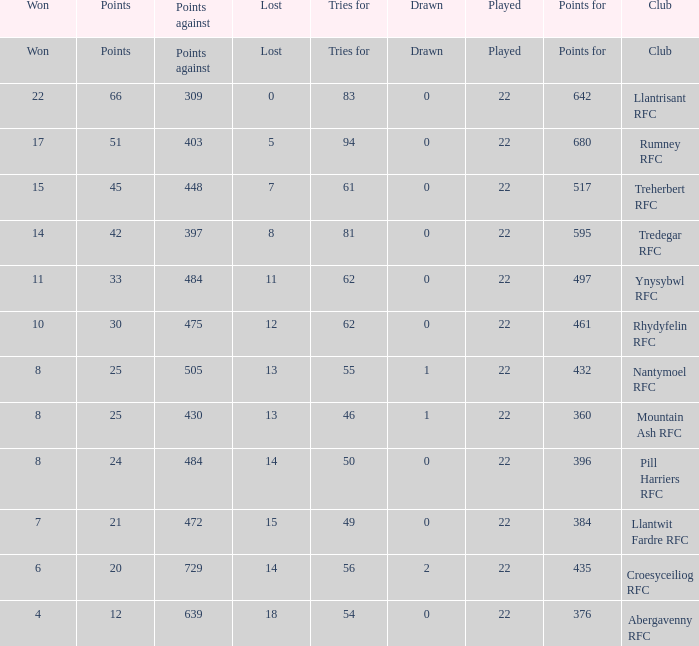How many matches were drawn by the teams that won exactly 10? 1.0. 